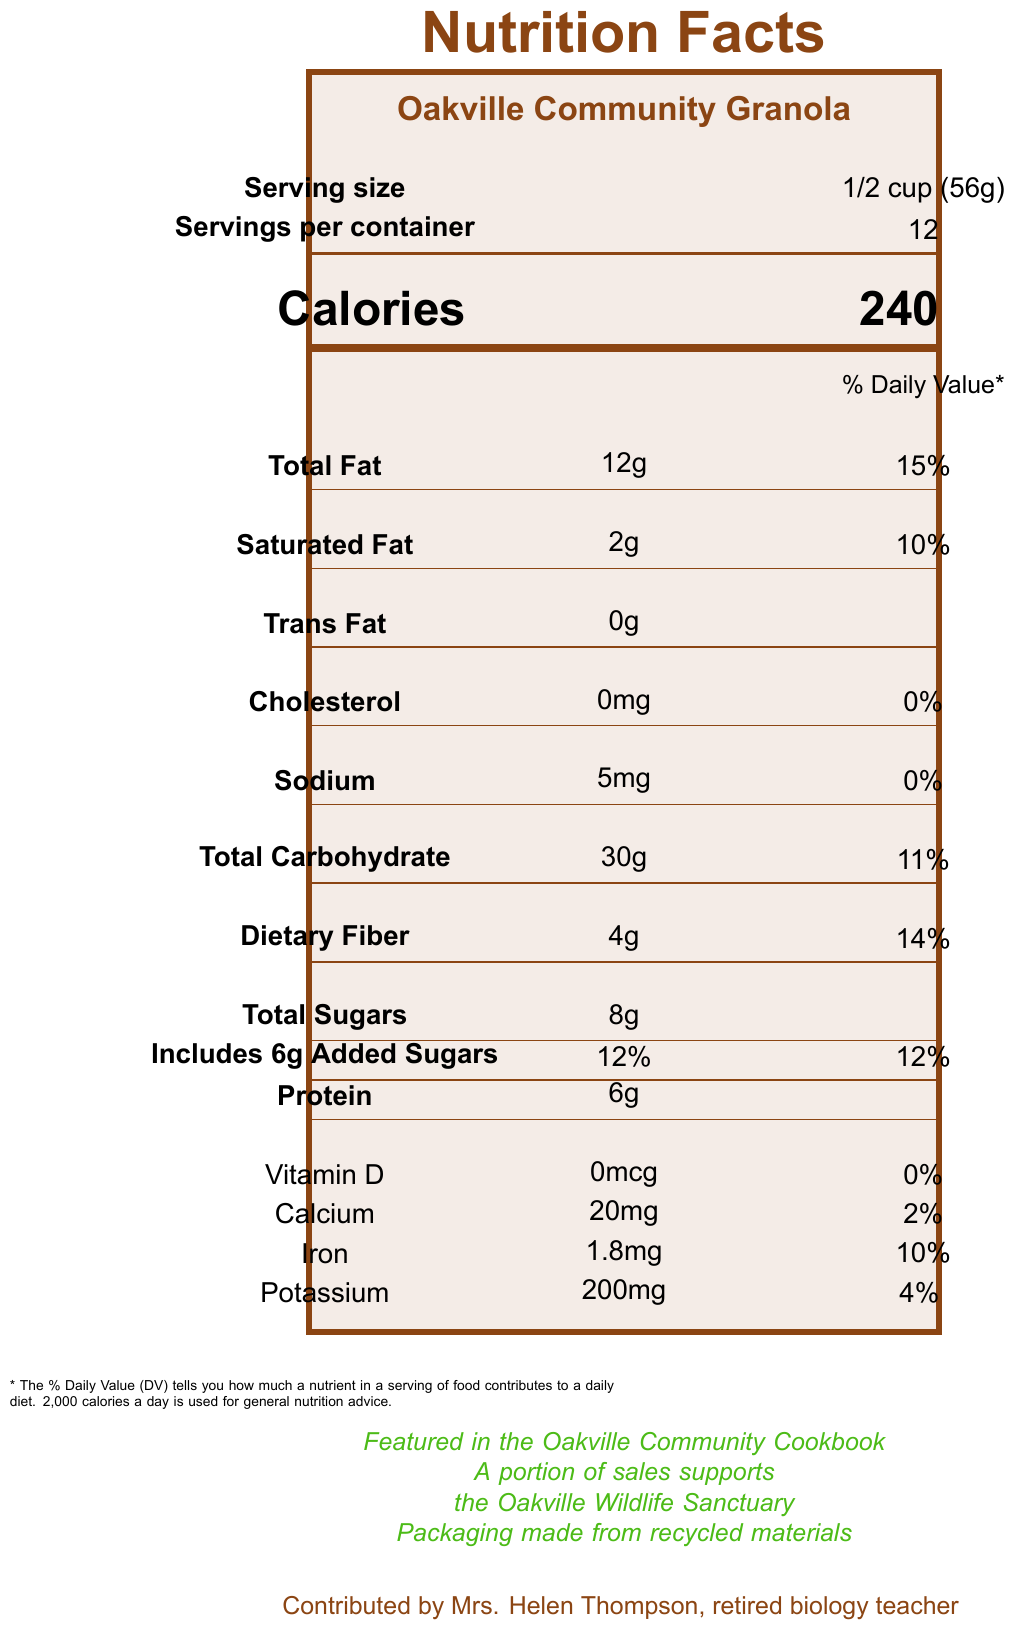what is the serving size of the Oakville Community Granola? The serving size is explicitly listed as "1/2 cup (56g)" on the document.
Answer: 1/2 cup (56g) how many calories are there per serving? The document clearly states "Calories" followed by the number "240".
Answer: 240 calories how many grams of dietary fiber are in each serving? Under the "Nutrients" section, "Dietary Fiber" is listed with an amount of "4g".
Answer: 4g what is the percentage daily value of saturated fat? The document lists "Saturated Fat" with a daily value of "10%".
Answer: 10% what should you do if you want to store the granola for up to two weeks? The storage instructions state to "Store in an airtight container at room temperature for up to 2 weeks".
Answer: Store it in an airtight container at room temperature how much sodium is in one serving of the granola? "Sodium" is listed with the amount "5mg" in the document.
Answer: 5mg what is true about the origin of the granola recipe? A. It was contributed by a chef B. It was contributed by a nutritionist C. It was contributed by a retired biology teacher D. It was a family recipe The document states that the recipe was "Contributed by Mrs. Helen Thompson, retired biology teacher".
Answer: C. It was contributed by a retired biology teacher which of the following statements about the granola is true? A. It contains peanuts B. It has no added sugars C. It contains tree nuts (almonds) D. It includes artificial preservatives The "allergens" section clearly mentions "Contains tree nuts (almonds)".
Answer: C. It contains tree nuts (almonds) is there any cholesterol in the granola? The document lists "Cholesterol" with the amount "0mg", indicating there is no cholesterol in the granola.
Answer: No please summarize the main idea of the document The document offers a detailed look at the nutritional content of the granola, emphasizing its health benefits, origin, storage, and community support-note.
Answer: The document provides comprehensive nutritional information about Oakville Community Granola, including its serving size, calories, amounts of various nutrients, ingredients, allergens, and storage instructions. It also mentions that the recipe was contributed by Mrs. Helen Thompson and highlights that a portion of sales supports the Oakville Wildlife Sanctuary. how much vitamin D is in the granola? The document lists "Vitamin D" with the amount "0mcg".
Answer: 0mcg how long can you store the granola at room temperature? The storage instructions clearly state it can be "Stored in an airtight container at room temperature for up to 2 weeks".
Answer: Up to 2 weeks what is the correct daily value percentage for added sugars in the granola? In the nutrient section, "Includes 6g Added Sugars" is listed with a daily value of "12%".
Answer: 12% who contributed the recipe for the Oakville Community Granola? The document specifies "Contributed by Mrs. Helen Thompson, retired biology teacher".
Answer: Mrs. Helen Thompson how many servings are there in the container? The document lists "Servings per container" as "12".
Answer: 12 servings can I find the nutritional information for vitamin C in this document? The document does not provide any details about the vitamin C content.
Answer: Not enough information 